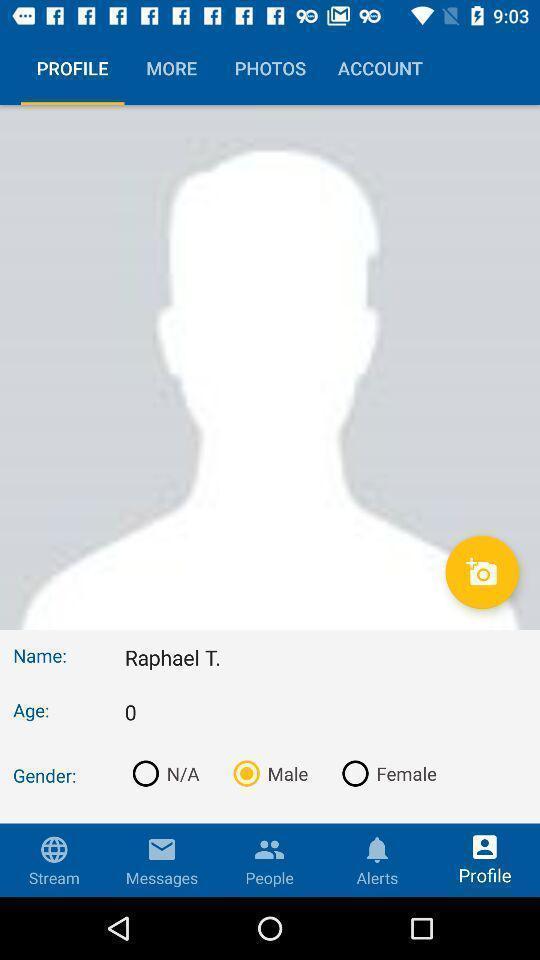Describe the content in this image. Profile with personal information in the application. 